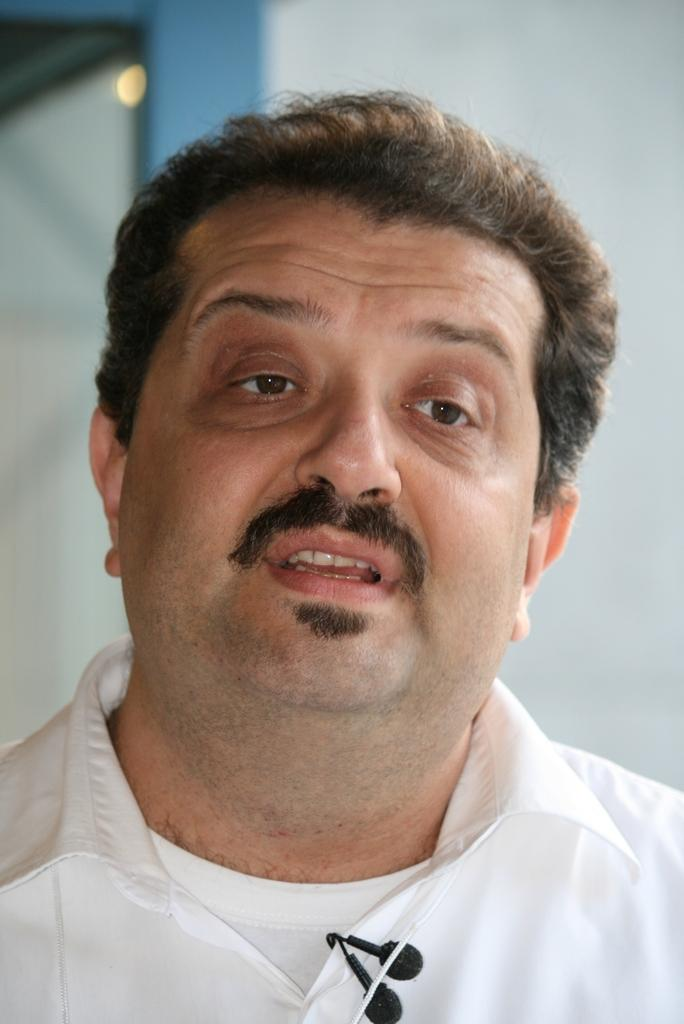What is the main subject of the image? There is a man in the image. What can be seen on the man's shirt? The man has "miles" written on his shirt. How would you describe the background of the image? The background of the image is blurry. What type of silk fabric is being used by the ghost in the image? There is no ghost present in the image, and therefore no silk fabric can be observed. 